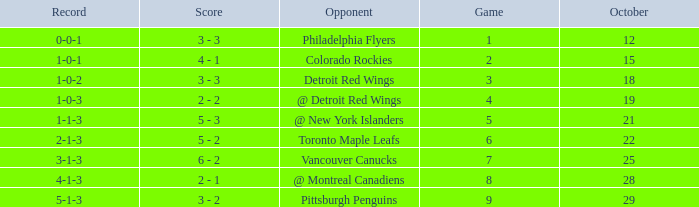Name the score for game more than 6 and before october 28 6 - 2. 